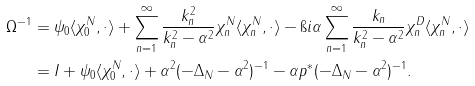<formula> <loc_0><loc_0><loc_500><loc_500>\Omega ^ { - 1 } & = \psi _ { 0 } \langle \chi _ { 0 } ^ { N } , \cdot \rangle + \sum _ { n = 1 } ^ { \infty } \frac { k _ { n } ^ { 2 } } { k _ { n } ^ { 2 } - \alpha ^ { 2 } } \chi _ { n } ^ { N } \langle \chi _ { n } ^ { N } , \cdot \rangle - \i i \alpha \sum _ { n = 1 } ^ { \infty } \frac { k _ { n } } { k _ { n } ^ { 2 } - \alpha ^ { 2 } } \chi _ { n } ^ { D } \langle \chi _ { n } ^ { N } , \cdot \rangle \\ & = I + \psi _ { 0 } \langle \chi _ { 0 } ^ { N } , \cdot \rangle + \alpha ^ { 2 } ( - \Delta _ { N } - \alpha ^ { 2 } ) ^ { - 1 } - \alpha p ^ { * } ( - \Delta _ { N } - \alpha ^ { 2 } ) ^ { - 1 } .</formula> 